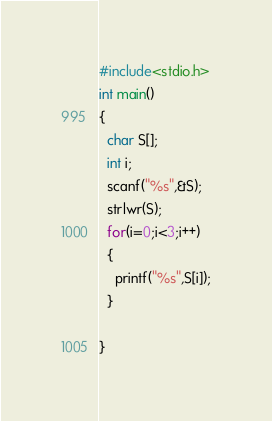Convert code to text. <code><loc_0><loc_0><loc_500><loc_500><_C_>#include<stdio.h>
int main()
{
  char S[];
  int i;
  scanf("%s",&S);
  strlwr(S);
  for(i=0;i<3;i++)
  {
    printf("%s",S[i]);
  }
  
}</code> 